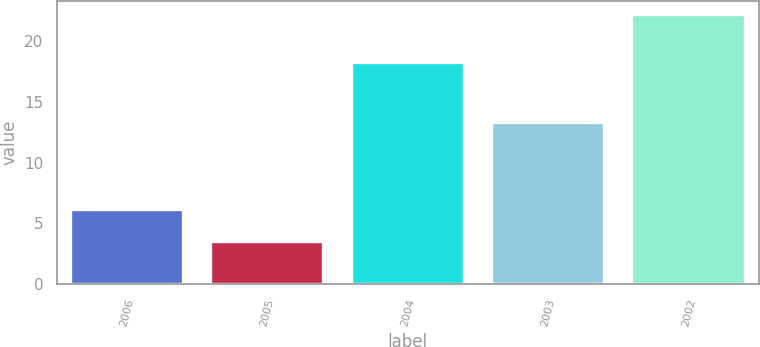Convert chart to OTSL. <chart><loc_0><loc_0><loc_500><loc_500><bar_chart><fcel>2006<fcel>2005<fcel>2004<fcel>2003<fcel>2002<nl><fcel>6.1<fcel>3.5<fcel>18.2<fcel>13.3<fcel>22.2<nl></chart> 